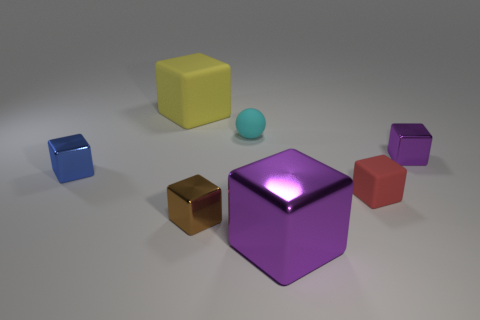Subtract all small blue cubes. How many cubes are left? 5 Subtract all purple blocks. How many blocks are left? 4 Subtract all yellow blocks. Subtract all purple cylinders. How many blocks are left? 5 Add 2 tiny yellow spheres. How many objects exist? 9 Subtract all spheres. How many objects are left? 6 Subtract all yellow matte spheres. Subtract all tiny blue metal things. How many objects are left? 6 Add 7 yellow rubber cubes. How many yellow rubber cubes are left? 8 Add 1 big green blocks. How many big green blocks exist? 1 Subtract 0 gray balls. How many objects are left? 7 